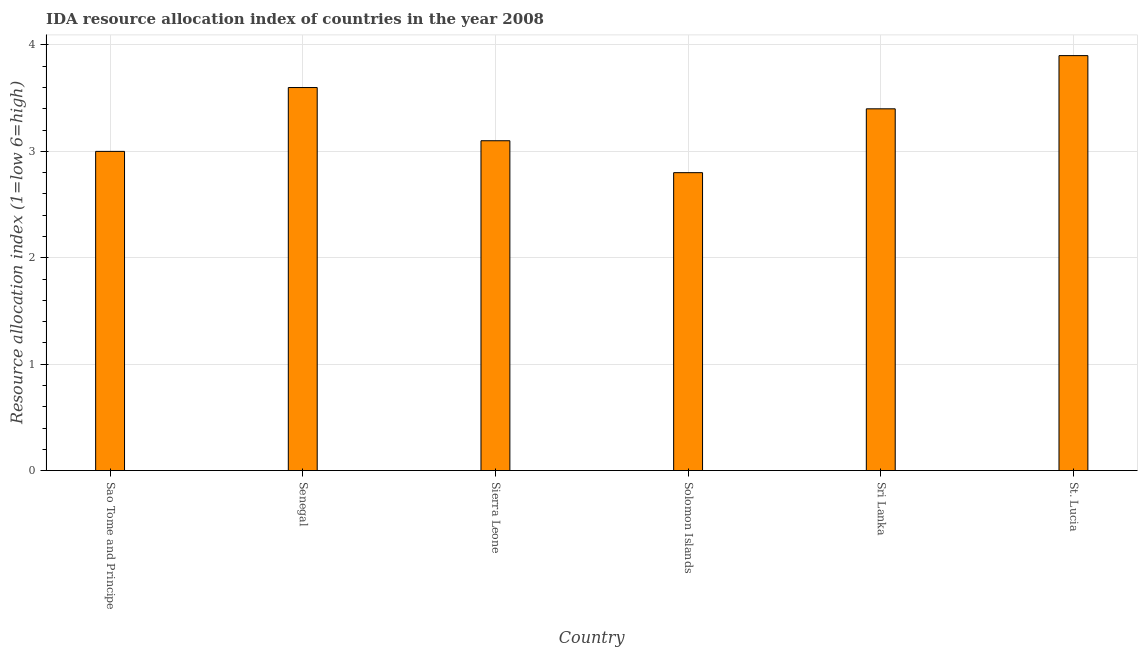What is the title of the graph?
Give a very brief answer. IDA resource allocation index of countries in the year 2008. What is the label or title of the Y-axis?
Give a very brief answer. Resource allocation index (1=low 6=high). What is the ida resource allocation index in St. Lucia?
Your answer should be compact. 3.9. Across all countries, what is the minimum ida resource allocation index?
Your response must be concise. 2.8. In which country was the ida resource allocation index maximum?
Provide a short and direct response. St. Lucia. In which country was the ida resource allocation index minimum?
Make the answer very short. Solomon Islands. What is the sum of the ida resource allocation index?
Provide a short and direct response. 19.8. What is the difference between the ida resource allocation index in Senegal and Sri Lanka?
Ensure brevity in your answer.  0.2. What is the median ida resource allocation index?
Your response must be concise. 3.25. In how many countries, is the ida resource allocation index greater than 3.4 ?
Make the answer very short. 2. What is the ratio of the ida resource allocation index in Sao Tome and Principe to that in Solomon Islands?
Give a very brief answer. 1.07. Is the ida resource allocation index in Sao Tome and Principe less than that in Sri Lanka?
Keep it short and to the point. Yes. Is the difference between the ida resource allocation index in Sri Lanka and St. Lucia greater than the difference between any two countries?
Ensure brevity in your answer.  No. What is the difference between the highest and the second highest ida resource allocation index?
Offer a terse response. 0.3. Are all the bars in the graph horizontal?
Offer a very short reply. No. What is the Resource allocation index (1=low 6=high) of Sao Tome and Principe?
Your answer should be very brief. 3. What is the Resource allocation index (1=low 6=high) in Senegal?
Offer a very short reply. 3.6. What is the Resource allocation index (1=low 6=high) in Sierra Leone?
Provide a short and direct response. 3.1. What is the Resource allocation index (1=low 6=high) in Sri Lanka?
Your answer should be very brief. 3.4. What is the difference between the Resource allocation index (1=low 6=high) in Sao Tome and Principe and Senegal?
Ensure brevity in your answer.  -0.6. What is the difference between the Resource allocation index (1=low 6=high) in Sao Tome and Principe and Solomon Islands?
Give a very brief answer. 0.2. What is the difference between the Resource allocation index (1=low 6=high) in Sao Tome and Principe and Sri Lanka?
Offer a terse response. -0.4. What is the difference between the Resource allocation index (1=low 6=high) in Sao Tome and Principe and St. Lucia?
Keep it short and to the point. -0.9. What is the difference between the Resource allocation index (1=low 6=high) in Senegal and Sierra Leone?
Give a very brief answer. 0.5. What is the difference between the Resource allocation index (1=low 6=high) in Senegal and St. Lucia?
Keep it short and to the point. -0.3. What is the difference between the Resource allocation index (1=low 6=high) in Sierra Leone and Sri Lanka?
Your response must be concise. -0.3. What is the difference between the Resource allocation index (1=low 6=high) in Sierra Leone and St. Lucia?
Provide a short and direct response. -0.8. What is the ratio of the Resource allocation index (1=low 6=high) in Sao Tome and Principe to that in Senegal?
Your response must be concise. 0.83. What is the ratio of the Resource allocation index (1=low 6=high) in Sao Tome and Principe to that in Solomon Islands?
Your answer should be very brief. 1.07. What is the ratio of the Resource allocation index (1=low 6=high) in Sao Tome and Principe to that in Sri Lanka?
Provide a succinct answer. 0.88. What is the ratio of the Resource allocation index (1=low 6=high) in Sao Tome and Principe to that in St. Lucia?
Make the answer very short. 0.77. What is the ratio of the Resource allocation index (1=low 6=high) in Senegal to that in Sierra Leone?
Your response must be concise. 1.16. What is the ratio of the Resource allocation index (1=low 6=high) in Senegal to that in Solomon Islands?
Your answer should be compact. 1.29. What is the ratio of the Resource allocation index (1=low 6=high) in Senegal to that in Sri Lanka?
Provide a short and direct response. 1.06. What is the ratio of the Resource allocation index (1=low 6=high) in Senegal to that in St. Lucia?
Provide a short and direct response. 0.92. What is the ratio of the Resource allocation index (1=low 6=high) in Sierra Leone to that in Solomon Islands?
Your answer should be very brief. 1.11. What is the ratio of the Resource allocation index (1=low 6=high) in Sierra Leone to that in Sri Lanka?
Provide a succinct answer. 0.91. What is the ratio of the Resource allocation index (1=low 6=high) in Sierra Leone to that in St. Lucia?
Your response must be concise. 0.8. What is the ratio of the Resource allocation index (1=low 6=high) in Solomon Islands to that in Sri Lanka?
Your answer should be compact. 0.82. What is the ratio of the Resource allocation index (1=low 6=high) in Solomon Islands to that in St. Lucia?
Offer a very short reply. 0.72. What is the ratio of the Resource allocation index (1=low 6=high) in Sri Lanka to that in St. Lucia?
Ensure brevity in your answer.  0.87. 